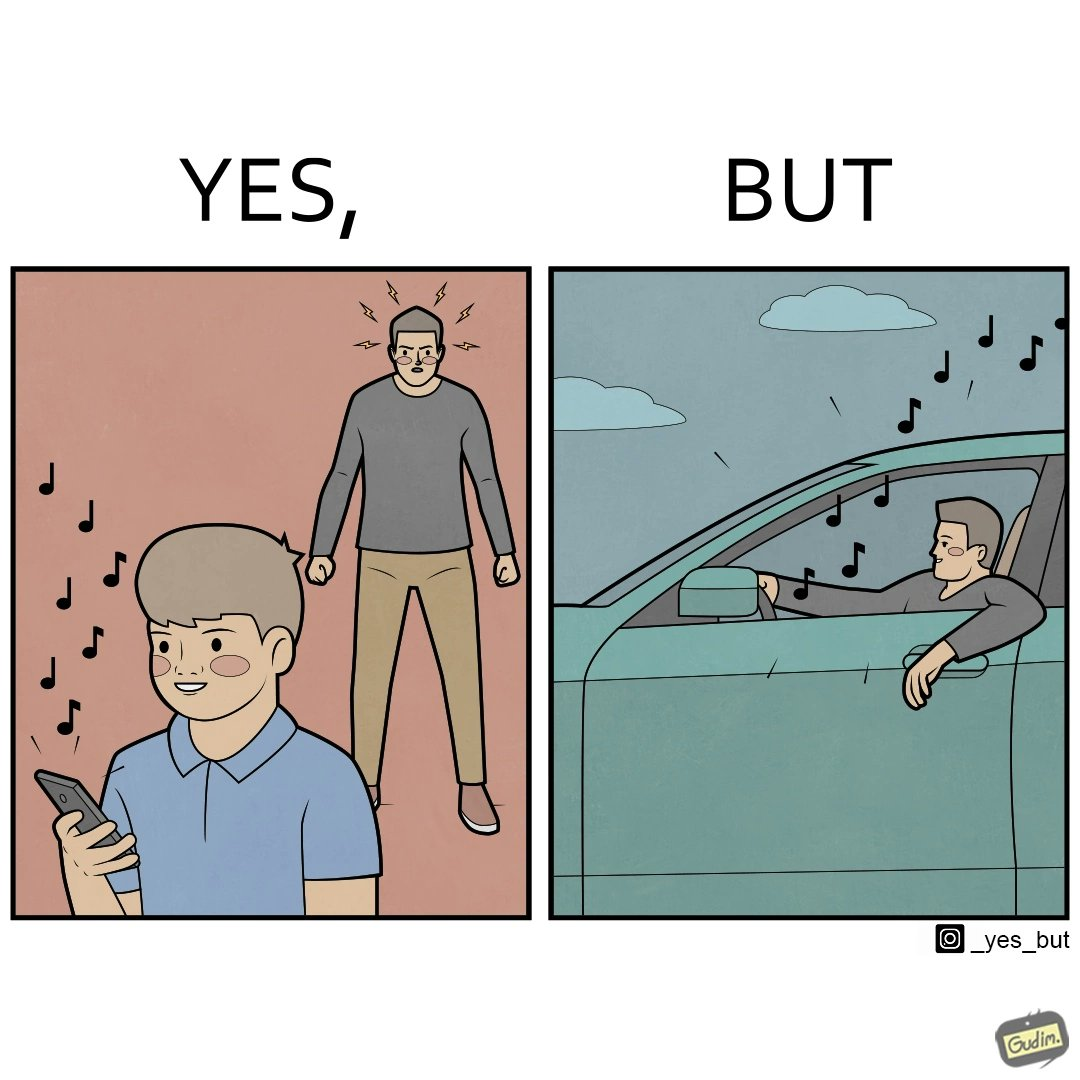Would you classify this image as satirical? Yes, this image is satirical. 